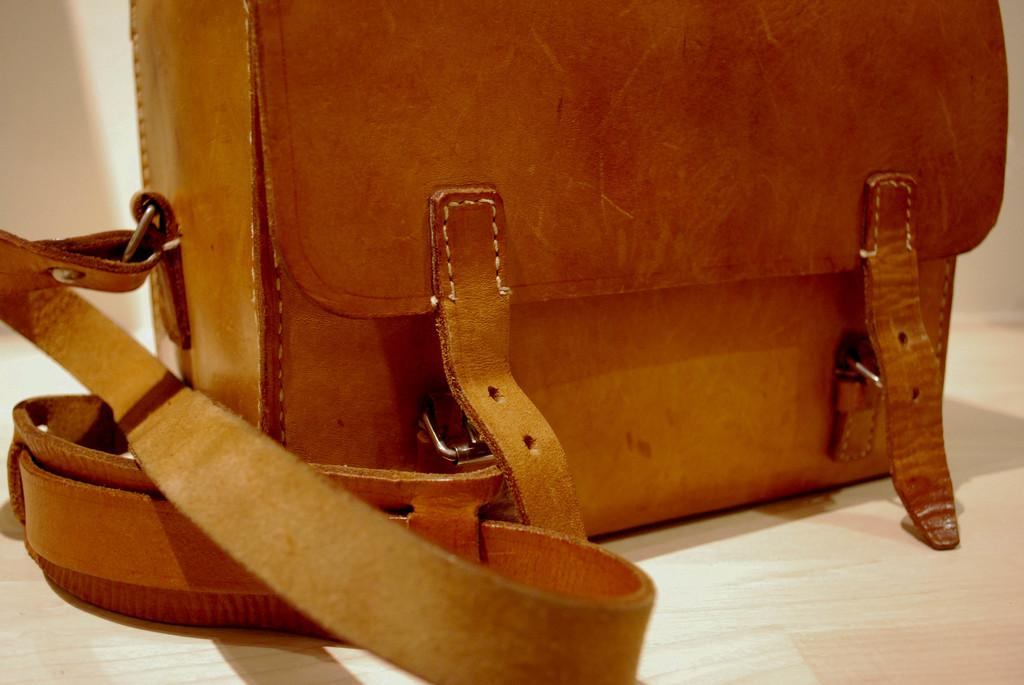What type of bag is visible in the image? There is a brown bag in the image. What feature does the brown bag have? The brown bag has a handle. What type of insurance is mentioned on the brown bag in the image? There is no mention of insurance on the brown bag in the image. Can you see any eggs in the image? There are no eggs present in the image. 